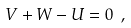Convert formula to latex. <formula><loc_0><loc_0><loc_500><loc_500>V + W - U = 0 \ ,</formula> 